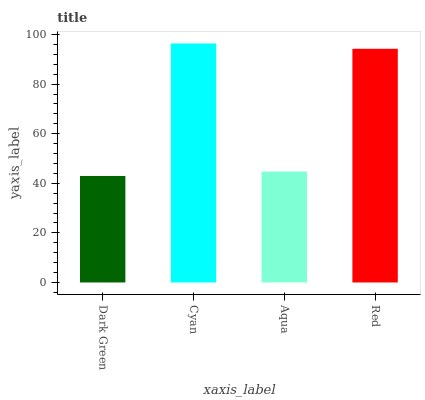Is Dark Green the minimum?
Answer yes or no. Yes. Is Cyan the maximum?
Answer yes or no. Yes. Is Aqua the minimum?
Answer yes or no. No. Is Aqua the maximum?
Answer yes or no. No. Is Cyan greater than Aqua?
Answer yes or no. Yes. Is Aqua less than Cyan?
Answer yes or no. Yes. Is Aqua greater than Cyan?
Answer yes or no. No. Is Cyan less than Aqua?
Answer yes or no. No. Is Red the high median?
Answer yes or no. Yes. Is Aqua the low median?
Answer yes or no. Yes. Is Cyan the high median?
Answer yes or no. No. Is Dark Green the low median?
Answer yes or no. No. 